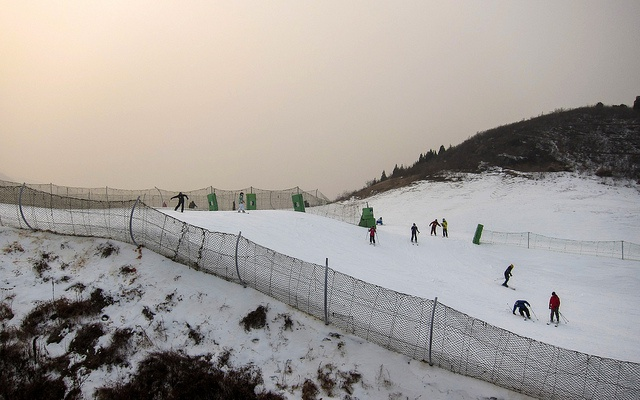Describe the objects in this image and their specific colors. I can see people in beige, black, maroon, gray, and darkgray tones, people in beige, black, gray, navy, and darkgray tones, people in beige, black, lightgray, darkgray, and gray tones, people in beige, black, gray, and darkgray tones, and people in beige, black, gray, and navy tones in this image. 